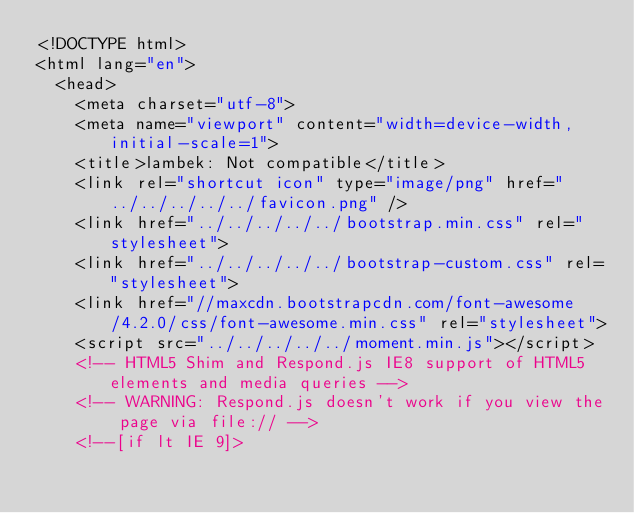Convert code to text. <code><loc_0><loc_0><loc_500><loc_500><_HTML_><!DOCTYPE html>
<html lang="en">
  <head>
    <meta charset="utf-8">
    <meta name="viewport" content="width=device-width, initial-scale=1">
    <title>lambek: Not compatible</title>
    <link rel="shortcut icon" type="image/png" href="../../../../../favicon.png" />
    <link href="../../../../../bootstrap.min.css" rel="stylesheet">
    <link href="../../../../../bootstrap-custom.css" rel="stylesheet">
    <link href="//maxcdn.bootstrapcdn.com/font-awesome/4.2.0/css/font-awesome.min.css" rel="stylesheet">
    <script src="../../../../../moment.min.js"></script>
    <!-- HTML5 Shim and Respond.js IE8 support of HTML5 elements and media queries -->
    <!-- WARNING: Respond.js doesn't work if you view the page via file:// -->
    <!--[if lt IE 9]></code> 